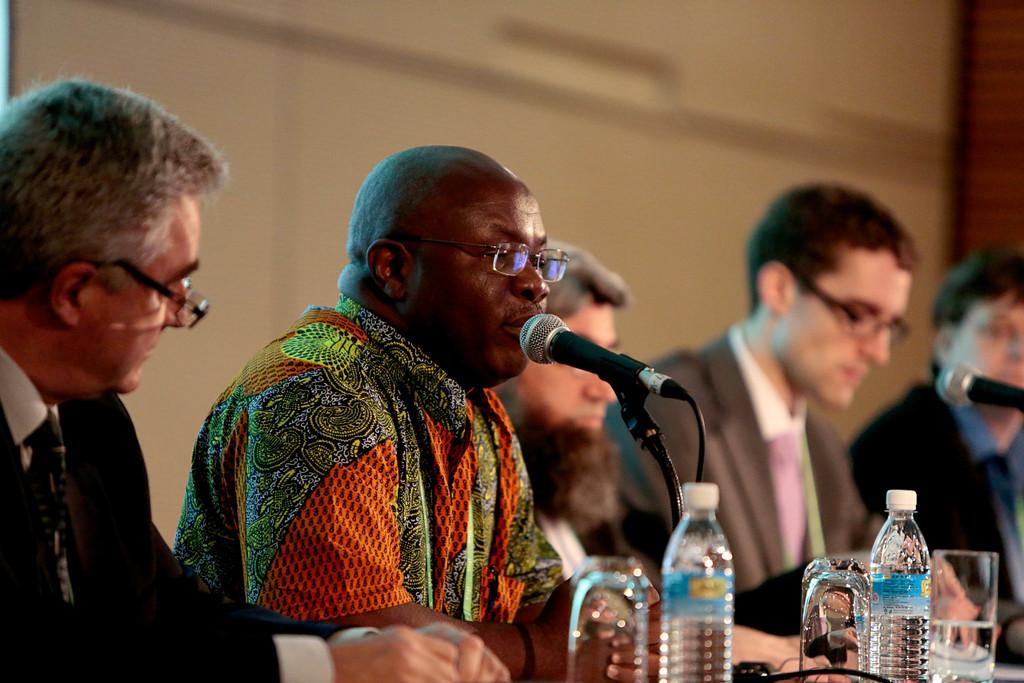What object is black and can be seen in the image? There is a black microphone in the image. What are the people in the image doing? The people are sitting in the image. What can be seen besides the people and the microphone? There are bottles visible in the image. What color is the wall in the background of the image? There is a brown color wall in the background of the image. How many desks are visible in the image? There are no desks present in the image. What type of building can be seen in the background of the image? There is no building visible in the image; only a brown color wall is present in the background. 